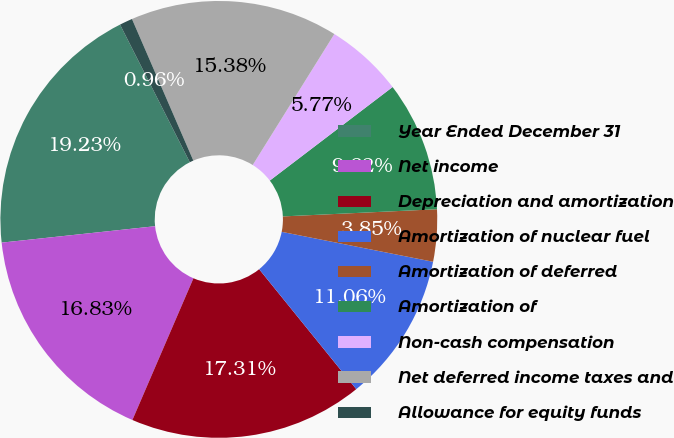<chart> <loc_0><loc_0><loc_500><loc_500><pie_chart><fcel>Year Ended December 31<fcel>Net income<fcel>Depreciation and amortization<fcel>Amortization of nuclear fuel<fcel>Amortization of deferred<fcel>Amortization of<fcel>Non-cash compensation<fcel>Net deferred income taxes and<fcel>Allowance for equity funds<nl><fcel>19.23%<fcel>16.83%<fcel>17.31%<fcel>11.06%<fcel>3.85%<fcel>9.62%<fcel>5.77%<fcel>15.38%<fcel>0.96%<nl></chart> 